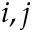<formula> <loc_0><loc_0><loc_500><loc_500>i , j</formula> 